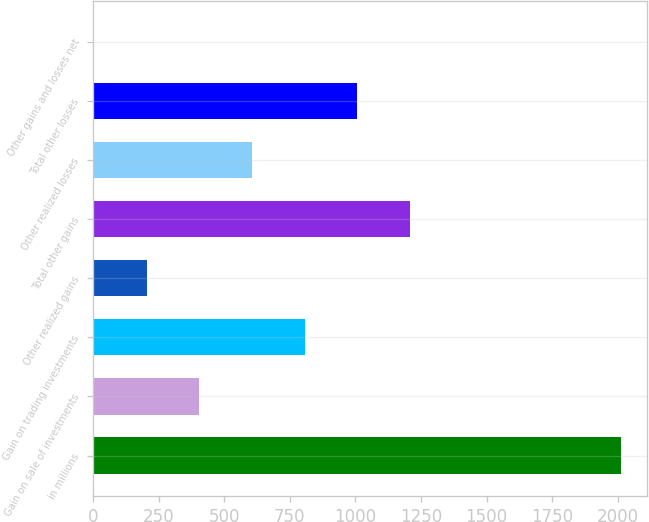<chart> <loc_0><loc_0><loc_500><loc_500><bar_chart><fcel>in millions<fcel>Gain on sale of investments<fcel>Gain on trading investments<fcel>Other realized gains<fcel>Total other gains<fcel>Other realized losses<fcel>Total other losses<fcel>Other gains and losses net<nl><fcel>2013<fcel>404.68<fcel>806.76<fcel>203.64<fcel>1208.84<fcel>605.72<fcel>1007.8<fcel>2.6<nl></chart> 